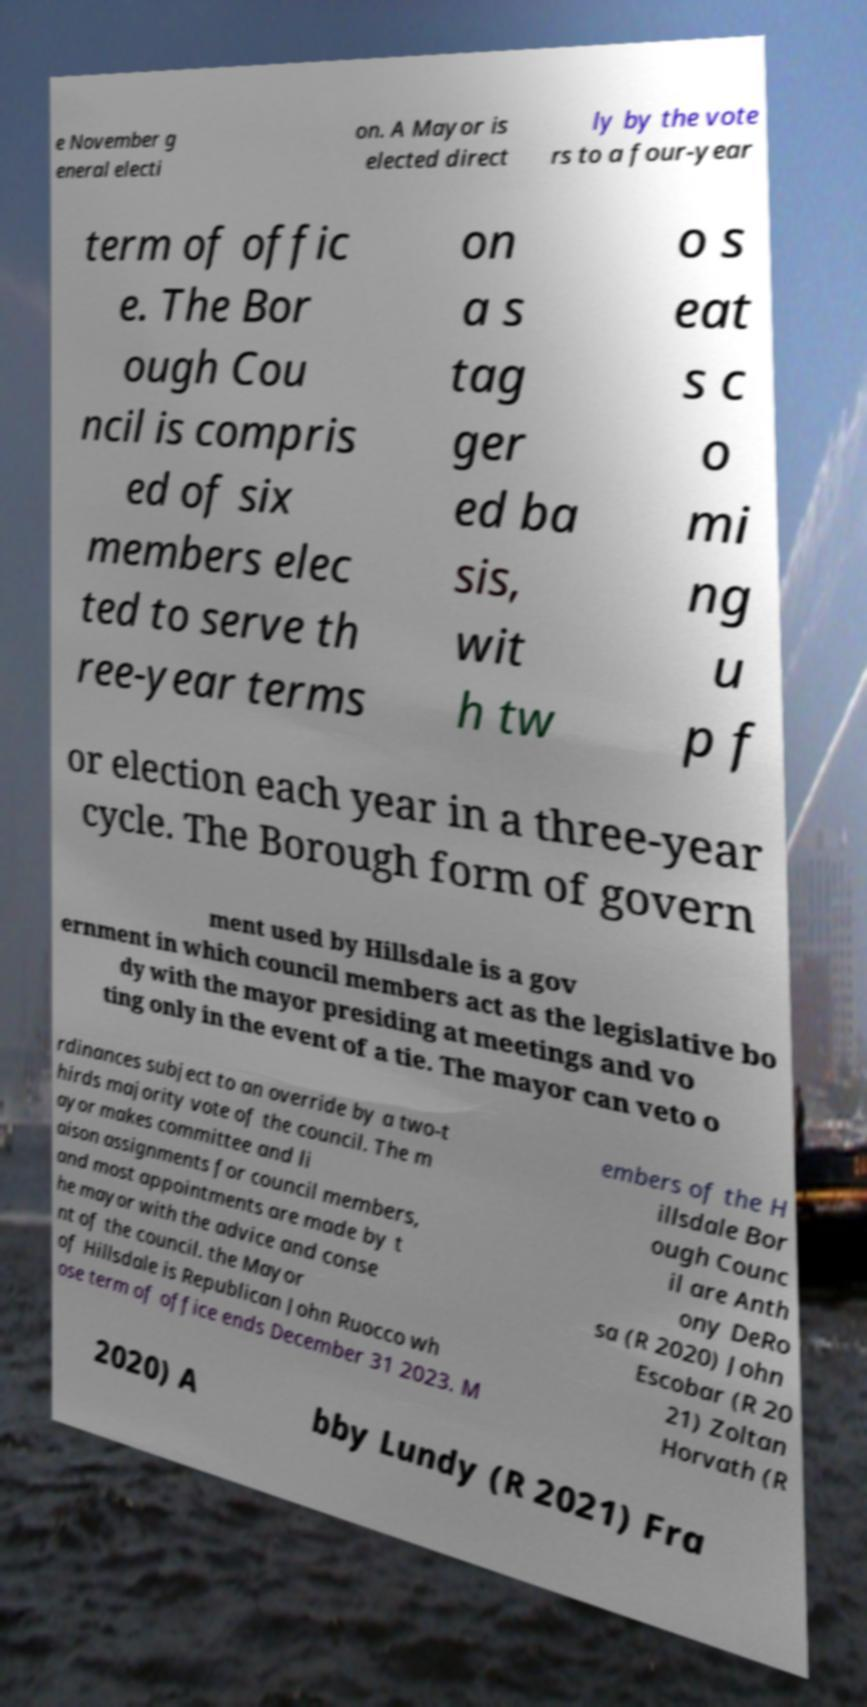Please read and relay the text visible in this image. What does it say? e November g eneral electi on. A Mayor is elected direct ly by the vote rs to a four-year term of offic e. The Bor ough Cou ncil is compris ed of six members elec ted to serve th ree-year terms on a s tag ger ed ba sis, wit h tw o s eat s c o mi ng u p f or election each year in a three-year cycle. The Borough form of govern ment used by Hillsdale is a gov ernment in which council members act as the legislative bo dy with the mayor presiding at meetings and vo ting only in the event of a tie. The mayor can veto o rdinances subject to an override by a two-t hirds majority vote of the council. The m ayor makes committee and li aison assignments for council members, and most appointments are made by t he mayor with the advice and conse nt of the council. the Mayor of Hillsdale is Republican John Ruocco wh ose term of office ends December 31 2023. M embers of the H illsdale Bor ough Counc il are Anth ony DeRo sa (R 2020) John Escobar (R 20 21) Zoltan Horvath (R 2020) A bby Lundy (R 2021) Fra 